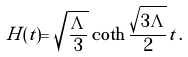<formula> <loc_0><loc_0><loc_500><loc_500>H ( t ) = \sqrt { \frac { \Lambda } { 3 } } \coth \frac { \sqrt { 3 \Lambda } } { 2 } t \, .</formula> 